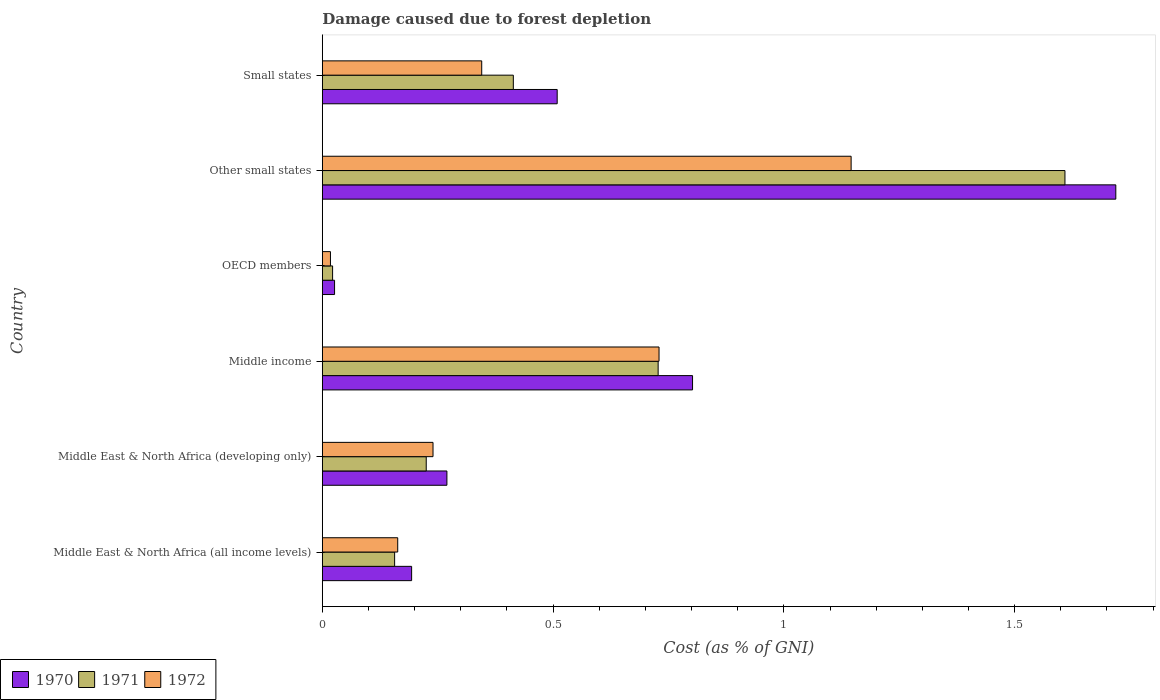How many groups of bars are there?
Make the answer very short. 6. Are the number of bars on each tick of the Y-axis equal?
Provide a short and direct response. Yes. How many bars are there on the 5th tick from the top?
Your answer should be very brief. 3. What is the label of the 1st group of bars from the top?
Offer a very short reply. Small states. What is the cost of damage caused due to forest depletion in 1971 in Other small states?
Make the answer very short. 1.61. Across all countries, what is the maximum cost of damage caused due to forest depletion in 1971?
Offer a terse response. 1.61. Across all countries, what is the minimum cost of damage caused due to forest depletion in 1971?
Your answer should be very brief. 0.02. In which country was the cost of damage caused due to forest depletion in 1970 maximum?
Keep it short and to the point. Other small states. In which country was the cost of damage caused due to forest depletion in 1970 minimum?
Ensure brevity in your answer.  OECD members. What is the total cost of damage caused due to forest depletion in 1972 in the graph?
Your answer should be compact. 2.64. What is the difference between the cost of damage caused due to forest depletion in 1971 in Middle East & North Africa (all income levels) and that in Other small states?
Your answer should be compact. -1.45. What is the difference between the cost of damage caused due to forest depletion in 1971 in Small states and the cost of damage caused due to forest depletion in 1970 in Middle East & North Africa (developing only)?
Ensure brevity in your answer.  0.14. What is the average cost of damage caused due to forest depletion in 1972 per country?
Give a very brief answer. 0.44. What is the difference between the cost of damage caused due to forest depletion in 1970 and cost of damage caused due to forest depletion in 1972 in Small states?
Make the answer very short. 0.16. In how many countries, is the cost of damage caused due to forest depletion in 1972 greater than 1.5 %?
Provide a short and direct response. 0. What is the ratio of the cost of damage caused due to forest depletion in 1971 in Middle East & North Africa (all income levels) to that in OECD members?
Your answer should be compact. 7.04. What is the difference between the highest and the second highest cost of damage caused due to forest depletion in 1971?
Offer a terse response. 0.88. What is the difference between the highest and the lowest cost of damage caused due to forest depletion in 1970?
Your answer should be compact. 1.69. In how many countries, is the cost of damage caused due to forest depletion in 1970 greater than the average cost of damage caused due to forest depletion in 1970 taken over all countries?
Give a very brief answer. 2. How many bars are there?
Ensure brevity in your answer.  18. Are all the bars in the graph horizontal?
Your answer should be compact. Yes. What is the difference between two consecutive major ticks on the X-axis?
Your response must be concise. 0.5. Where does the legend appear in the graph?
Ensure brevity in your answer.  Bottom left. What is the title of the graph?
Offer a terse response. Damage caused due to forest depletion. Does "1995" appear as one of the legend labels in the graph?
Ensure brevity in your answer.  No. What is the label or title of the X-axis?
Your answer should be compact. Cost (as % of GNI). What is the label or title of the Y-axis?
Your answer should be compact. Country. What is the Cost (as % of GNI) in 1970 in Middle East & North Africa (all income levels)?
Offer a terse response. 0.19. What is the Cost (as % of GNI) of 1971 in Middle East & North Africa (all income levels)?
Offer a terse response. 0.16. What is the Cost (as % of GNI) in 1972 in Middle East & North Africa (all income levels)?
Give a very brief answer. 0.16. What is the Cost (as % of GNI) of 1970 in Middle East & North Africa (developing only)?
Provide a succinct answer. 0.27. What is the Cost (as % of GNI) in 1971 in Middle East & North Africa (developing only)?
Keep it short and to the point. 0.23. What is the Cost (as % of GNI) of 1972 in Middle East & North Africa (developing only)?
Ensure brevity in your answer.  0.24. What is the Cost (as % of GNI) of 1970 in Middle income?
Your response must be concise. 0.8. What is the Cost (as % of GNI) of 1971 in Middle income?
Provide a succinct answer. 0.73. What is the Cost (as % of GNI) in 1972 in Middle income?
Give a very brief answer. 0.73. What is the Cost (as % of GNI) in 1970 in OECD members?
Your answer should be very brief. 0.03. What is the Cost (as % of GNI) of 1971 in OECD members?
Provide a succinct answer. 0.02. What is the Cost (as % of GNI) of 1972 in OECD members?
Your answer should be compact. 0.02. What is the Cost (as % of GNI) in 1970 in Other small states?
Offer a terse response. 1.72. What is the Cost (as % of GNI) of 1971 in Other small states?
Offer a very short reply. 1.61. What is the Cost (as % of GNI) of 1972 in Other small states?
Make the answer very short. 1.15. What is the Cost (as % of GNI) in 1970 in Small states?
Offer a very short reply. 0.51. What is the Cost (as % of GNI) in 1971 in Small states?
Ensure brevity in your answer.  0.41. What is the Cost (as % of GNI) in 1972 in Small states?
Keep it short and to the point. 0.35. Across all countries, what is the maximum Cost (as % of GNI) of 1970?
Your answer should be very brief. 1.72. Across all countries, what is the maximum Cost (as % of GNI) in 1971?
Provide a succinct answer. 1.61. Across all countries, what is the maximum Cost (as % of GNI) in 1972?
Your answer should be very brief. 1.15. Across all countries, what is the minimum Cost (as % of GNI) of 1970?
Ensure brevity in your answer.  0.03. Across all countries, what is the minimum Cost (as % of GNI) in 1971?
Your answer should be very brief. 0.02. Across all countries, what is the minimum Cost (as % of GNI) in 1972?
Your answer should be compact. 0.02. What is the total Cost (as % of GNI) of 1970 in the graph?
Ensure brevity in your answer.  3.52. What is the total Cost (as % of GNI) of 1971 in the graph?
Provide a short and direct response. 3.15. What is the total Cost (as % of GNI) of 1972 in the graph?
Your answer should be compact. 2.64. What is the difference between the Cost (as % of GNI) of 1970 in Middle East & North Africa (all income levels) and that in Middle East & North Africa (developing only)?
Your answer should be very brief. -0.08. What is the difference between the Cost (as % of GNI) in 1971 in Middle East & North Africa (all income levels) and that in Middle East & North Africa (developing only)?
Provide a short and direct response. -0.07. What is the difference between the Cost (as % of GNI) of 1972 in Middle East & North Africa (all income levels) and that in Middle East & North Africa (developing only)?
Provide a succinct answer. -0.08. What is the difference between the Cost (as % of GNI) in 1970 in Middle East & North Africa (all income levels) and that in Middle income?
Your answer should be compact. -0.61. What is the difference between the Cost (as % of GNI) in 1971 in Middle East & North Africa (all income levels) and that in Middle income?
Provide a short and direct response. -0.57. What is the difference between the Cost (as % of GNI) in 1972 in Middle East & North Africa (all income levels) and that in Middle income?
Provide a succinct answer. -0.57. What is the difference between the Cost (as % of GNI) in 1970 in Middle East & North Africa (all income levels) and that in OECD members?
Offer a terse response. 0.17. What is the difference between the Cost (as % of GNI) in 1971 in Middle East & North Africa (all income levels) and that in OECD members?
Ensure brevity in your answer.  0.13. What is the difference between the Cost (as % of GNI) in 1972 in Middle East & North Africa (all income levels) and that in OECD members?
Offer a very short reply. 0.15. What is the difference between the Cost (as % of GNI) in 1970 in Middle East & North Africa (all income levels) and that in Other small states?
Offer a very short reply. -1.53. What is the difference between the Cost (as % of GNI) of 1971 in Middle East & North Africa (all income levels) and that in Other small states?
Provide a short and direct response. -1.45. What is the difference between the Cost (as % of GNI) in 1972 in Middle East & North Africa (all income levels) and that in Other small states?
Your response must be concise. -0.98. What is the difference between the Cost (as % of GNI) in 1970 in Middle East & North Africa (all income levels) and that in Small states?
Your response must be concise. -0.32. What is the difference between the Cost (as % of GNI) of 1971 in Middle East & North Africa (all income levels) and that in Small states?
Offer a terse response. -0.26. What is the difference between the Cost (as % of GNI) of 1972 in Middle East & North Africa (all income levels) and that in Small states?
Your response must be concise. -0.18. What is the difference between the Cost (as % of GNI) in 1970 in Middle East & North Africa (developing only) and that in Middle income?
Ensure brevity in your answer.  -0.53. What is the difference between the Cost (as % of GNI) of 1971 in Middle East & North Africa (developing only) and that in Middle income?
Your response must be concise. -0.5. What is the difference between the Cost (as % of GNI) in 1972 in Middle East & North Africa (developing only) and that in Middle income?
Provide a short and direct response. -0.49. What is the difference between the Cost (as % of GNI) of 1970 in Middle East & North Africa (developing only) and that in OECD members?
Provide a short and direct response. 0.24. What is the difference between the Cost (as % of GNI) of 1971 in Middle East & North Africa (developing only) and that in OECD members?
Provide a short and direct response. 0.2. What is the difference between the Cost (as % of GNI) in 1972 in Middle East & North Africa (developing only) and that in OECD members?
Provide a succinct answer. 0.22. What is the difference between the Cost (as % of GNI) in 1970 in Middle East & North Africa (developing only) and that in Other small states?
Provide a succinct answer. -1.45. What is the difference between the Cost (as % of GNI) in 1971 in Middle East & North Africa (developing only) and that in Other small states?
Offer a terse response. -1.38. What is the difference between the Cost (as % of GNI) of 1972 in Middle East & North Africa (developing only) and that in Other small states?
Your response must be concise. -0.91. What is the difference between the Cost (as % of GNI) of 1970 in Middle East & North Africa (developing only) and that in Small states?
Give a very brief answer. -0.24. What is the difference between the Cost (as % of GNI) of 1971 in Middle East & North Africa (developing only) and that in Small states?
Offer a very short reply. -0.19. What is the difference between the Cost (as % of GNI) of 1972 in Middle East & North Africa (developing only) and that in Small states?
Offer a very short reply. -0.11. What is the difference between the Cost (as % of GNI) in 1970 in Middle income and that in OECD members?
Provide a short and direct response. 0.78. What is the difference between the Cost (as % of GNI) in 1971 in Middle income and that in OECD members?
Keep it short and to the point. 0.71. What is the difference between the Cost (as % of GNI) of 1972 in Middle income and that in OECD members?
Your answer should be compact. 0.71. What is the difference between the Cost (as % of GNI) of 1970 in Middle income and that in Other small states?
Provide a short and direct response. -0.92. What is the difference between the Cost (as % of GNI) in 1971 in Middle income and that in Other small states?
Make the answer very short. -0.88. What is the difference between the Cost (as % of GNI) of 1972 in Middle income and that in Other small states?
Give a very brief answer. -0.42. What is the difference between the Cost (as % of GNI) in 1970 in Middle income and that in Small states?
Provide a short and direct response. 0.29. What is the difference between the Cost (as % of GNI) in 1971 in Middle income and that in Small states?
Your answer should be compact. 0.31. What is the difference between the Cost (as % of GNI) in 1972 in Middle income and that in Small states?
Your answer should be compact. 0.38. What is the difference between the Cost (as % of GNI) of 1970 in OECD members and that in Other small states?
Your answer should be compact. -1.69. What is the difference between the Cost (as % of GNI) in 1971 in OECD members and that in Other small states?
Provide a short and direct response. -1.59. What is the difference between the Cost (as % of GNI) in 1972 in OECD members and that in Other small states?
Offer a very short reply. -1.13. What is the difference between the Cost (as % of GNI) of 1970 in OECD members and that in Small states?
Your answer should be very brief. -0.48. What is the difference between the Cost (as % of GNI) of 1971 in OECD members and that in Small states?
Offer a terse response. -0.39. What is the difference between the Cost (as % of GNI) of 1972 in OECD members and that in Small states?
Offer a terse response. -0.33. What is the difference between the Cost (as % of GNI) in 1970 in Other small states and that in Small states?
Provide a short and direct response. 1.21. What is the difference between the Cost (as % of GNI) in 1971 in Other small states and that in Small states?
Ensure brevity in your answer.  1.2. What is the difference between the Cost (as % of GNI) in 1972 in Other small states and that in Small states?
Offer a terse response. 0.8. What is the difference between the Cost (as % of GNI) in 1970 in Middle East & North Africa (all income levels) and the Cost (as % of GNI) in 1971 in Middle East & North Africa (developing only)?
Your response must be concise. -0.03. What is the difference between the Cost (as % of GNI) in 1970 in Middle East & North Africa (all income levels) and the Cost (as % of GNI) in 1972 in Middle East & North Africa (developing only)?
Your answer should be compact. -0.05. What is the difference between the Cost (as % of GNI) in 1971 in Middle East & North Africa (all income levels) and the Cost (as % of GNI) in 1972 in Middle East & North Africa (developing only)?
Keep it short and to the point. -0.08. What is the difference between the Cost (as % of GNI) of 1970 in Middle East & North Africa (all income levels) and the Cost (as % of GNI) of 1971 in Middle income?
Make the answer very short. -0.53. What is the difference between the Cost (as % of GNI) in 1970 in Middle East & North Africa (all income levels) and the Cost (as % of GNI) in 1972 in Middle income?
Make the answer very short. -0.54. What is the difference between the Cost (as % of GNI) in 1971 in Middle East & North Africa (all income levels) and the Cost (as % of GNI) in 1972 in Middle income?
Keep it short and to the point. -0.57. What is the difference between the Cost (as % of GNI) in 1970 in Middle East & North Africa (all income levels) and the Cost (as % of GNI) in 1971 in OECD members?
Make the answer very short. 0.17. What is the difference between the Cost (as % of GNI) of 1970 in Middle East & North Africa (all income levels) and the Cost (as % of GNI) of 1972 in OECD members?
Offer a very short reply. 0.18. What is the difference between the Cost (as % of GNI) of 1971 in Middle East & North Africa (all income levels) and the Cost (as % of GNI) of 1972 in OECD members?
Your response must be concise. 0.14. What is the difference between the Cost (as % of GNI) of 1970 in Middle East & North Africa (all income levels) and the Cost (as % of GNI) of 1971 in Other small states?
Make the answer very short. -1.42. What is the difference between the Cost (as % of GNI) in 1970 in Middle East & North Africa (all income levels) and the Cost (as % of GNI) in 1972 in Other small states?
Keep it short and to the point. -0.95. What is the difference between the Cost (as % of GNI) in 1971 in Middle East & North Africa (all income levels) and the Cost (as % of GNI) in 1972 in Other small states?
Offer a very short reply. -0.99. What is the difference between the Cost (as % of GNI) of 1970 in Middle East & North Africa (all income levels) and the Cost (as % of GNI) of 1971 in Small states?
Give a very brief answer. -0.22. What is the difference between the Cost (as % of GNI) in 1970 in Middle East & North Africa (all income levels) and the Cost (as % of GNI) in 1972 in Small states?
Provide a short and direct response. -0.15. What is the difference between the Cost (as % of GNI) of 1971 in Middle East & North Africa (all income levels) and the Cost (as % of GNI) of 1972 in Small states?
Ensure brevity in your answer.  -0.19. What is the difference between the Cost (as % of GNI) in 1970 in Middle East & North Africa (developing only) and the Cost (as % of GNI) in 1971 in Middle income?
Provide a short and direct response. -0.46. What is the difference between the Cost (as % of GNI) in 1970 in Middle East & North Africa (developing only) and the Cost (as % of GNI) in 1972 in Middle income?
Provide a succinct answer. -0.46. What is the difference between the Cost (as % of GNI) of 1971 in Middle East & North Africa (developing only) and the Cost (as % of GNI) of 1972 in Middle income?
Provide a succinct answer. -0.5. What is the difference between the Cost (as % of GNI) in 1970 in Middle East & North Africa (developing only) and the Cost (as % of GNI) in 1971 in OECD members?
Keep it short and to the point. 0.25. What is the difference between the Cost (as % of GNI) of 1970 in Middle East & North Africa (developing only) and the Cost (as % of GNI) of 1972 in OECD members?
Your answer should be compact. 0.25. What is the difference between the Cost (as % of GNI) of 1971 in Middle East & North Africa (developing only) and the Cost (as % of GNI) of 1972 in OECD members?
Offer a terse response. 0.21. What is the difference between the Cost (as % of GNI) of 1970 in Middle East & North Africa (developing only) and the Cost (as % of GNI) of 1971 in Other small states?
Give a very brief answer. -1.34. What is the difference between the Cost (as % of GNI) in 1970 in Middle East & North Africa (developing only) and the Cost (as % of GNI) in 1972 in Other small states?
Your answer should be very brief. -0.88. What is the difference between the Cost (as % of GNI) of 1971 in Middle East & North Africa (developing only) and the Cost (as % of GNI) of 1972 in Other small states?
Ensure brevity in your answer.  -0.92. What is the difference between the Cost (as % of GNI) of 1970 in Middle East & North Africa (developing only) and the Cost (as % of GNI) of 1971 in Small states?
Make the answer very short. -0.14. What is the difference between the Cost (as % of GNI) of 1970 in Middle East & North Africa (developing only) and the Cost (as % of GNI) of 1972 in Small states?
Your response must be concise. -0.08. What is the difference between the Cost (as % of GNI) in 1971 in Middle East & North Africa (developing only) and the Cost (as % of GNI) in 1972 in Small states?
Provide a short and direct response. -0.12. What is the difference between the Cost (as % of GNI) of 1970 in Middle income and the Cost (as % of GNI) of 1971 in OECD members?
Ensure brevity in your answer.  0.78. What is the difference between the Cost (as % of GNI) of 1970 in Middle income and the Cost (as % of GNI) of 1972 in OECD members?
Your answer should be very brief. 0.78. What is the difference between the Cost (as % of GNI) in 1971 in Middle income and the Cost (as % of GNI) in 1972 in OECD members?
Offer a terse response. 0.71. What is the difference between the Cost (as % of GNI) of 1970 in Middle income and the Cost (as % of GNI) of 1971 in Other small states?
Provide a succinct answer. -0.81. What is the difference between the Cost (as % of GNI) in 1970 in Middle income and the Cost (as % of GNI) in 1972 in Other small states?
Provide a short and direct response. -0.34. What is the difference between the Cost (as % of GNI) in 1971 in Middle income and the Cost (as % of GNI) in 1972 in Other small states?
Make the answer very short. -0.42. What is the difference between the Cost (as % of GNI) in 1970 in Middle income and the Cost (as % of GNI) in 1971 in Small states?
Give a very brief answer. 0.39. What is the difference between the Cost (as % of GNI) in 1970 in Middle income and the Cost (as % of GNI) in 1972 in Small states?
Make the answer very short. 0.46. What is the difference between the Cost (as % of GNI) in 1971 in Middle income and the Cost (as % of GNI) in 1972 in Small states?
Provide a short and direct response. 0.38. What is the difference between the Cost (as % of GNI) of 1970 in OECD members and the Cost (as % of GNI) of 1971 in Other small states?
Provide a short and direct response. -1.58. What is the difference between the Cost (as % of GNI) of 1970 in OECD members and the Cost (as % of GNI) of 1972 in Other small states?
Keep it short and to the point. -1.12. What is the difference between the Cost (as % of GNI) of 1971 in OECD members and the Cost (as % of GNI) of 1972 in Other small states?
Make the answer very short. -1.12. What is the difference between the Cost (as % of GNI) of 1970 in OECD members and the Cost (as % of GNI) of 1971 in Small states?
Your answer should be compact. -0.39. What is the difference between the Cost (as % of GNI) of 1970 in OECD members and the Cost (as % of GNI) of 1972 in Small states?
Your answer should be very brief. -0.32. What is the difference between the Cost (as % of GNI) in 1971 in OECD members and the Cost (as % of GNI) in 1972 in Small states?
Give a very brief answer. -0.32. What is the difference between the Cost (as % of GNI) of 1970 in Other small states and the Cost (as % of GNI) of 1971 in Small states?
Make the answer very short. 1.31. What is the difference between the Cost (as % of GNI) of 1970 in Other small states and the Cost (as % of GNI) of 1972 in Small states?
Your answer should be very brief. 1.37. What is the difference between the Cost (as % of GNI) of 1971 in Other small states and the Cost (as % of GNI) of 1972 in Small states?
Make the answer very short. 1.26. What is the average Cost (as % of GNI) of 1970 per country?
Make the answer very short. 0.59. What is the average Cost (as % of GNI) in 1971 per country?
Your answer should be compact. 0.53. What is the average Cost (as % of GNI) in 1972 per country?
Give a very brief answer. 0.44. What is the difference between the Cost (as % of GNI) in 1970 and Cost (as % of GNI) in 1971 in Middle East & North Africa (all income levels)?
Keep it short and to the point. 0.04. What is the difference between the Cost (as % of GNI) in 1970 and Cost (as % of GNI) in 1972 in Middle East & North Africa (all income levels)?
Offer a very short reply. 0.03. What is the difference between the Cost (as % of GNI) in 1971 and Cost (as % of GNI) in 1972 in Middle East & North Africa (all income levels)?
Keep it short and to the point. -0.01. What is the difference between the Cost (as % of GNI) of 1970 and Cost (as % of GNI) of 1971 in Middle East & North Africa (developing only)?
Give a very brief answer. 0.04. What is the difference between the Cost (as % of GNI) in 1970 and Cost (as % of GNI) in 1972 in Middle East & North Africa (developing only)?
Give a very brief answer. 0.03. What is the difference between the Cost (as % of GNI) of 1971 and Cost (as % of GNI) of 1972 in Middle East & North Africa (developing only)?
Offer a very short reply. -0.01. What is the difference between the Cost (as % of GNI) in 1970 and Cost (as % of GNI) in 1971 in Middle income?
Make the answer very short. 0.07. What is the difference between the Cost (as % of GNI) of 1970 and Cost (as % of GNI) of 1972 in Middle income?
Provide a short and direct response. 0.07. What is the difference between the Cost (as % of GNI) of 1971 and Cost (as % of GNI) of 1972 in Middle income?
Give a very brief answer. -0. What is the difference between the Cost (as % of GNI) of 1970 and Cost (as % of GNI) of 1971 in OECD members?
Provide a short and direct response. 0. What is the difference between the Cost (as % of GNI) of 1970 and Cost (as % of GNI) of 1972 in OECD members?
Make the answer very short. 0.01. What is the difference between the Cost (as % of GNI) in 1971 and Cost (as % of GNI) in 1972 in OECD members?
Keep it short and to the point. 0. What is the difference between the Cost (as % of GNI) of 1970 and Cost (as % of GNI) of 1971 in Other small states?
Provide a succinct answer. 0.11. What is the difference between the Cost (as % of GNI) in 1970 and Cost (as % of GNI) in 1972 in Other small states?
Provide a short and direct response. 0.57. What is the difference between the Cost (as % of GNI) of 1971 and Cost (as % of GNI) of 1972 in Other small states?
Make the answer very short. 0.46. What is the difference between the Cost (as % of GNI) in 1970 and Cost (as % of GNI) in 1971 in Small states?
Offer a very short reply. 0.1. What is the difference between the Cost (as % of GNI) in 1970 and Cost (as % of GNI) in 1972 in Small states?
Offer a terse response. 0.16. What is the difference between the Cost (as % of GNI) of 1971 and Cost (as % of GNI) of 1972 in Small states?
Keep it short and to the point. 0.07. What is the ratio of the Cost (as % of GNI) of 1970 in Middle East & North Africa (all income levels) to that in Middle East & North Africa (developing only)?
Give a very brief answer. 0.72. What is the ratio of the Cost (as % of GNI) of 1971 in Middle East & North Africa (all income levels) to that in Middle East & North Africa (developing only)?
Make the answer very short. 0.7. What is the ratio of the Cost (as % of GNI) in 1972 in Middle East & North Africa (all income levels) to that in Middle East & North Africa (developing only)?
Provide a succinct answer. 0.68. What is the ratio of the Cost (as % of GNI) in 1970 in Middle East & North Africa (all income levels) to that in Middle income?
Offer a terse response. 0.24. What is the ratio of the Cost (as % of GNI) of 1971 in Middle East & North Africa (all income levels) to that in Middle income?
Make the answer very short. 0.22. What is the ratio of the Cost (as % of GNI) of 1972 in Middle East & North Africa (all income levels) to that in Middle income?
Provide a short and direct response. 0.22. What is the ratio of the Cost (as % of GNI) of 1970 in Middle East & North Africa (all income levels) to that in OECD members?
Your response must be concise. 7.3. What is the ratio of the Cost (as % of GNI) in 1971 in Middle East & North Africa (all income levels) to that in OECD members?
Provide a short and direct response. 7.04. What is the ratio of the Cost (as % of GNI) of 1972 in Middle East & North Africa (all income levels) to that in OECD members?
Offer a terse response. 9.29. What is the ratio of the Cost (as % of GNI) of 1970 in Middle East & North Africa (all income levels) to that in Other small states?
Your response must be concise. 0.11. What is the ratio of the Cost (as % of GNI) in 1971 in Middle East & North Africa (all income levels) to that in Other small states?
Give a very brief answer. 0.1. What is the ratio of the Cost (as % of GNI) of 1972 in Middle East & North Africa (all income levels) to that in Other small states?
Offer a terse response. 0.14. What is the ratio of the Cost (as % of GNI) of 1970 in Middle East & North Africa (all income levels) to that in Small states?
Your response must be concise. 0.38. What is the ratio of the Cost (as % of GNI) in 1971 in Middle East & North Africa (all income levels) to that in Small states?
Offer a terse response. 0.38. What is the ratio of the Cost (as % of GNI) of 1972 in Middle East & North Africa (all income levels) to that in Small states?
Your response must be concise. 0.47. What is the ratio of the Cost (as % of GNI) of 1970 in Middle East & North Africa (developing only) to that in Middle income?
Provide a succinct answer. 0.34. What is the ratio of the Cost (as % of GNI) of 1971 in Middle East & North Africa (developing only) to that in Middle income?
Ensure brevity in your answer.  0.31. What is the ratio of the Cost (as % of GNI) of 1972 in Middle East & North Africa (developing only) to that in Middle income?
Keep it short and to the point. 0.33. What is the ratio of the Cost (as % of GNI) in 1970 in Middle East & North Africa (developing only) to that in OECD members?
Keep it short and to the point. 10.19. What is the ratio of the Cost (as % of GNI) in 1971 in Middle East & North Africa (developing only) to that in OECD members?
Ensure brevity in your answer.  10.12. What is the ratio of the Cost (as % of GNI) in 1972 in Middle East & North Africa (developing only) to that in OECD members?
Your answer should be compact. 13.63. What is the ratio of the Cost (as % of GNI) of 1970 in Middle East & North Africa (developing only) to that in Other small states?
Make the answer very short. 0.16. What is the ratio of the Cost (as % of GNI) of 1971 in Middle East & North Africa (developing only) to that in Other small states?
Offer a terse response. 0.14. What is the ratio of the Cost (as % of GNI) of 1972 in Middle East & North Africa (developing only) to that in Other small states?
Provide a succinct answer. 0.21. What is the ratio of the Cost (as % of GNI) of 1970 in Middle East & North Africa (developing only) to that in Small states?
Provide a succinct answer. 0.53. What is the ratio of the Cost (as % of GNI) of 1971 in Middle East & North Africa (developing only) to that in Small states?
Make the answer very short. 0.54. What is the ratio of the Cost (as % of GNI) of 1972 in Middle East & North Africa (developing only) to that in Small states?
Your answer should be compact. 0.69. What is the ratio of the Cost (as % of GNI) in 1970 in Middle income to that in OECD members?
Provide a succinct answer. 30.28. What is the ratio of the Cost (as % of GNI) in 1971 in Middle income to that in OECD members?
Ensure brevity in your answer.  32.71. What is the ratio of the Cost (as % of GNI) of 1972 in Middle income to that in OECD members?
Your answer should be very brief. 41.48. What is the ratio of the Cost (as % of GNI) in 1970 in Middle income to that in Other small states?
Make the answer very short. 0.47. What is the ratio of the Cost (as % of GNI) of 1971 in Middle income to that in Other small states?
Ensure brevity in your answer.  0.45. What is the ratio of the Cost (as % of GNI) in 1972 in Middle income to that in Other small states?
Offer a very short reply. 0.64. What is the ratio of the Cost (as % of GNI) of 1970 in Middle income to that in Small states?
Keep it short and to the point. 1.58. What is the ratio of the Cost (as % of GNI) of 1971 in Middle income to that in Small states?
Your response must be concise. 1.76. What is the ratio of the Cost (as % of GNI) of 1972 in Middle income to that in Small states?
Keep it short and to the point. 2.11. What is the ratio of the Cost (as % of GNI) in 1970 in OECD members to that in Other small states?
Give a very brief answer. 0.02. What is the ratio of the Cost (as % of GNI) of 1971 in OECD members to that in Other small states?
Your answer should be very brief. 0.01. What is the ratio of the Cost (as % of GNI) in 1972 in OECD members to that in Other small states?
Provide a succinct answer. 0.02. What is the ratio of the Cost (as % of GNI) of 1970 in OECD members to that in Small states?
Offer a very short reply. 0.05. What is the ratio of the Cost (as % of GNI) in 1971 in OECD members to that in Small states?
Make the answer very short. 0.05. What is the ratio of the Cost (as % of GNI) in 1972 in OECD members to that in Small states?
Your response must be concise. 0.05. What is the ratio of the Cost (as % of GNI) of 1970 in Other small states to that in Small states?
Give a very brief answer. 3.38. What is the ratio of the Cost (as % of GNI) in 1971 in Other small states to that in Small states?
Provide a succinct answer. 3.89. What is the ratio of the Cost (as % of GNI) in 1972 in Other small states to that in Small states?
Give a very brief answer. 3.32. What is the difference between the highest and the second highest Cost (as % of GNI) in 1970?
Your answer should be compact. 0.92. What is the difference between the highest and the second highest Cost (as % of GNI) in 1971?
Provide a short and direct response. 0.88. What is the difference between the highest and the second highest Cost (as % of GNI) of 1972?
Keep it short and to the point. 0.42. What is the difference between the highest and the lowest Cost (as % of GNI) of 1970?
Your answer should be compact. 1.69. What is the difference between the highest and the lowest Cost (as % of GNI) of 1971?
Provide a succinct answer. 1.59. What is the difference between the highest and the lowest Cost (as % of GNI) of 1972?
Your answer should be very brief. 1.13. 